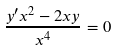Convert formula to latex. <formula><loc_0><loc_0><loc_500><loc_500>\frac { y ^ { \prime } x ^ { 2 } - 2 x y } { x ^ { 4 } } = 0</formula> 